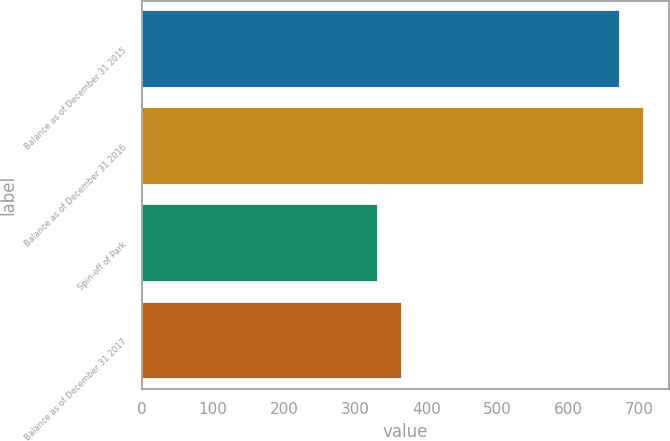Convert chart. <chart><loc_0><loc_0><loc_500><loc_500><bar_chart><fcel>Balance as of December 31 2015<fcel>Balance as of December 31 2016<fcel>Spin-off of Park<fcel>Balance as of December 31 2017<nl><fcel>672<fcel>706<fcel>332<fcel>366<nl></chart> 